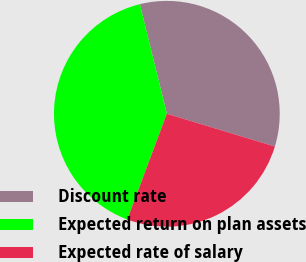Convert chart. <chart><loc_0><loc_0><loc_500><loc_500><pie_chart><fcel>Discount rate<fcel>Expected return on plan assets<fcel>Expected rate of salary<nl><fcel>33.53%<fcel>40.46%<fcel>26.01%<nl></chart> 